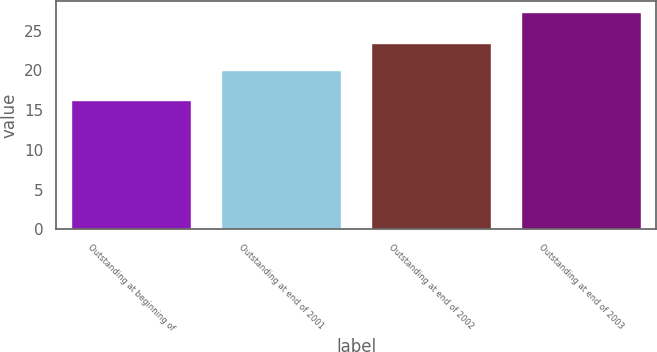Convert chart to OTSL. <chart><loc_0><loc_0><loc_500><loc_500><bar_chart><fcel>Outstanding at beginning of<fcel>Outstanding at end of 2001<fcel>Outstanding at end of 2002<fcel>Outstanding at end of 2003<nl><fcel>16.25<fcel>20.03<fcel>23.5<fcel>27.38<nl></chart> 